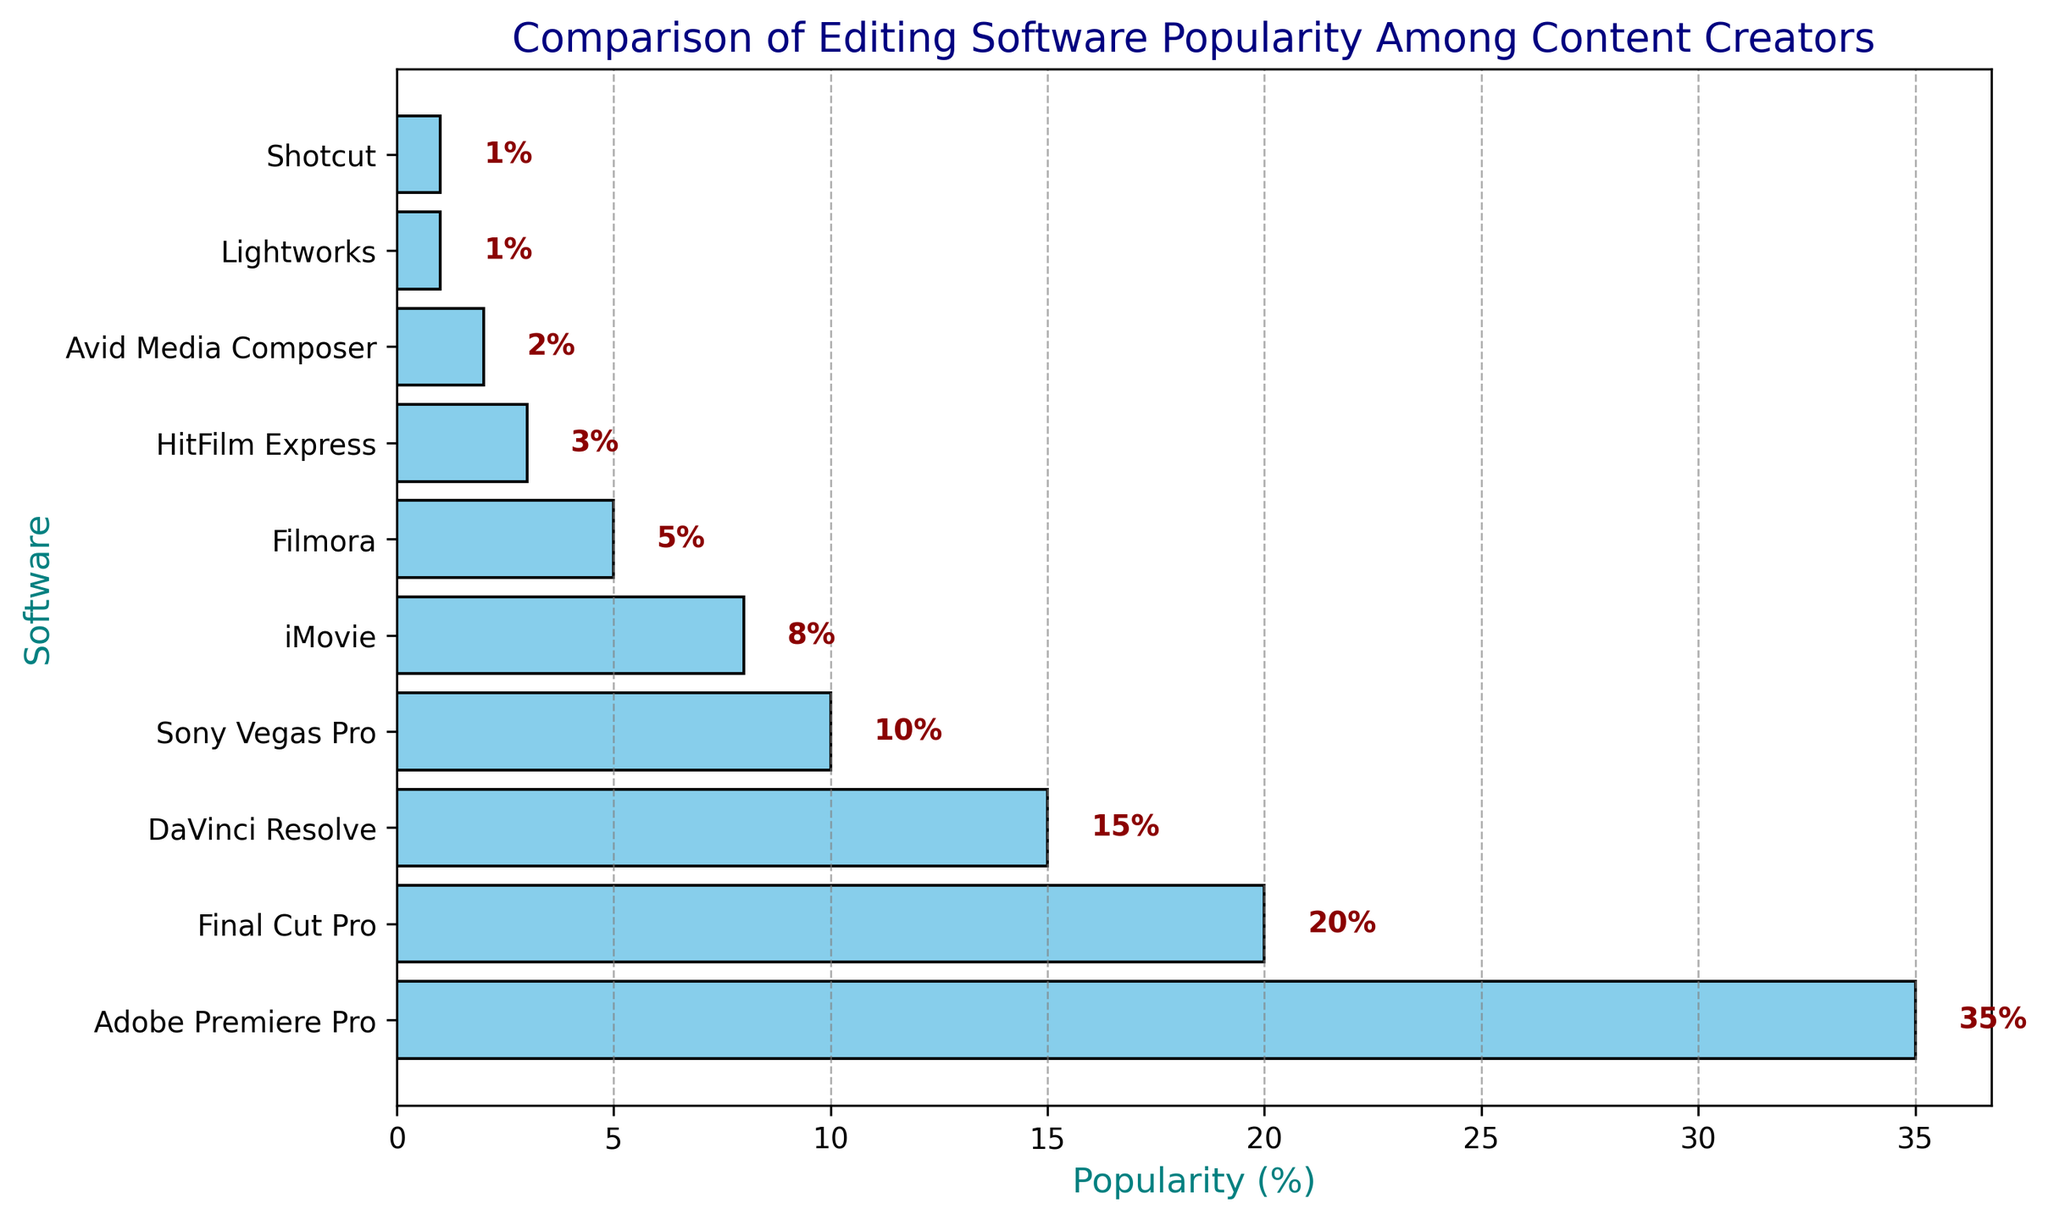What is the most popular editing software among content creators? The bar representing Adobe Premiere Pro has the highest percentage, indicating that it is the most popular.
Answer: Adobe Premiere Pro Which two editing software have equal popularity? Both Lightworks and Shotcut have bars with a popularity of 1%, making them equal in popularity.
Answer: Lightworks and Shotcut Which software is more popular, Sony Vegas Pro or DaVinci Resolve? The bar for DaVinci Resolve is higher than the bar for Sony Vegas Pro, indicating it is more popular.
Answer: DaVinci Resolve How much more popular is Adobe Premiere Pro compared to Final Cut Pro? The popularity of Adobe Premiere Pro is 35% and Final Cut Pro is 20%, so the difference is 35 - 20 = 15%.
Answer: 15% What is the combined popularity percentage of the top three software? The top three software are Adobe Premiere Pro (35%), Final Cut Pro (20%), and DaVinci Resolve (15%). Summing these gives 35 + 20 + 15 = 70%.
Answer: 70% Which software has the least popularity and what is its percentage? The bar for Lightworks and Shotcut are both the shortest, each with a popularity of 1%.
Answer: Lightworks and Shotcut, 1% Is the popularity of iMovie greater than or less than the combined popularity of HitFilm Express and Avid Media Composer? The bar for iMovie shows a popularity of 8%. HitFilm Express is 3% and Avid Media Composer is 2%; combined, they are 5%. Since 8 is greater than 5, iMovie is more popular.
Answer: Greater What is the average popularity percentage of Filmora, HitFilm Express, and Avid Media Composer? The popularity percentages are Filmora (5%), HitFilm Express (3%), and Avid Media Composer (2%). The average is (5 + 3 + 2) / 3 = 10 / 3 ≈ 3.33%.
Answer: 3.33% Which software has a popularity of less than 10% but more than 5%? The bars representing Filmora (5%), iMovie (8%), and Sony Vegas Pro (10%) are not candidates. The remaining bar for DaVinci Resolve (15%) is too high. HitFilm Express at 3% is too low. Therefore, iMovie meets the criteria.
Answer: iMovie 